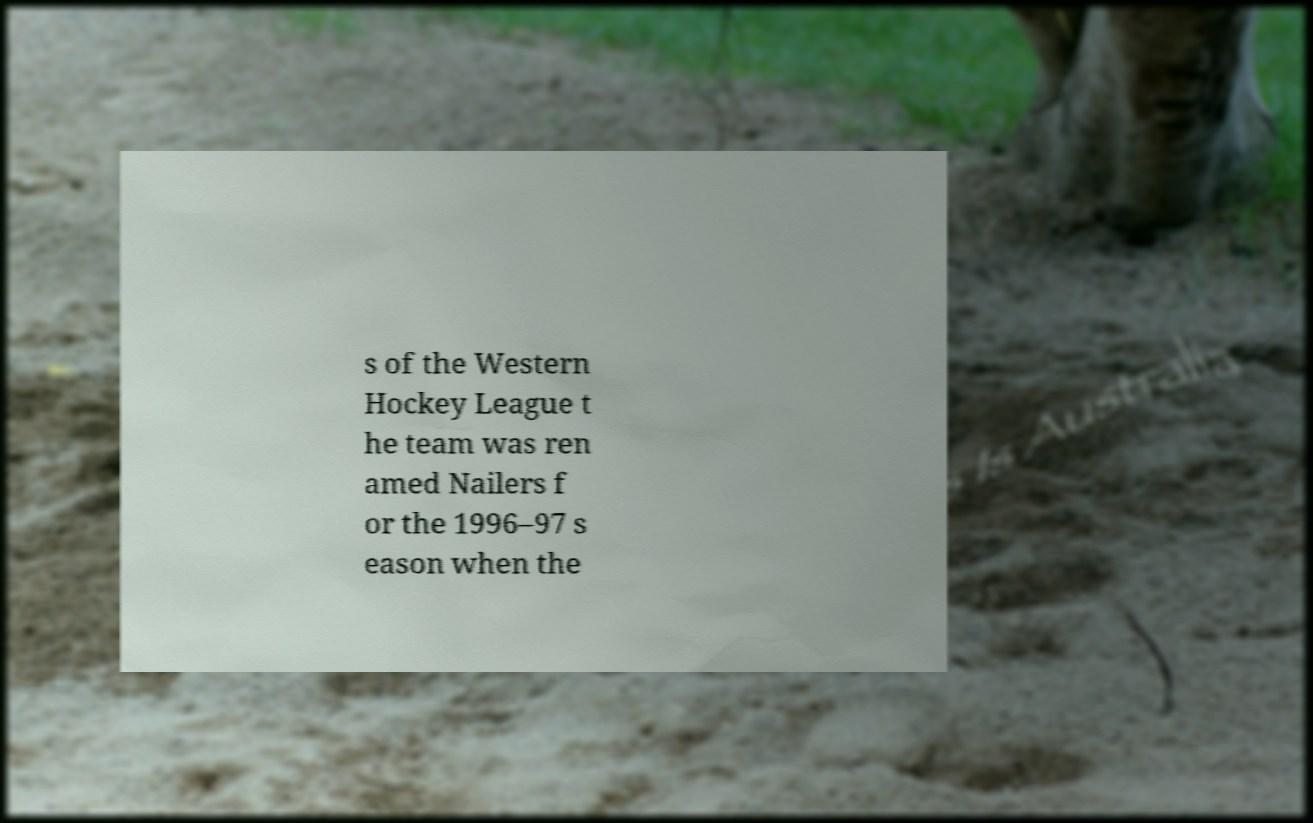Could you assist in decoding the text presented in this image and type it out clearly? s of the Western Hockey League t he team was ren amed Nailers f or the 1996–97 s eason when the 